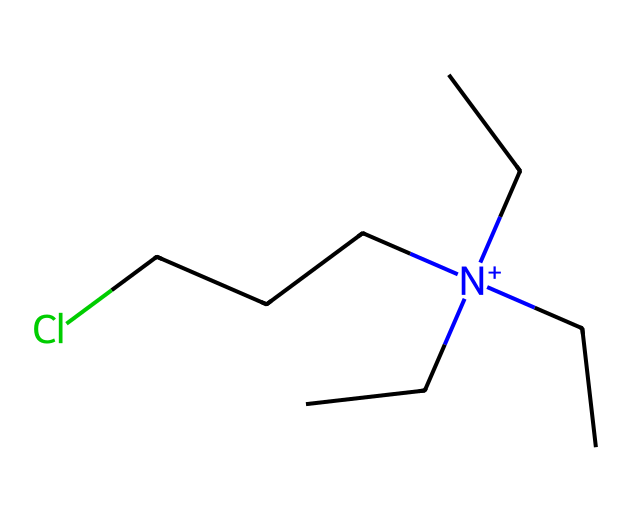What is the total number of carbon atoms in this compound? The SMILES representation shows multiple carbon atoms indicated by "C". Counting the number of "C" in the structure leads to a total of 7 carbon atoms.
Answer: 7 How many chlorine atoms are present in the chemical structure? The SMILES includes a "Cl" at the end, indicating one chlorine atom is bonded to the quaternary ammonium compound.
Answer: 1 What is the oxidation state of nitrogen in this compound? In quaternary ammonium compounds, the nitrogen usually has a +4 oxidation state due to the four alkyl groups attached and the positive charge displayed by "[N+]".
Answer: +4 What type of chemical is represented by this structure? The structure features a quaternary nitrogen atom and long carbon chains, characteristic of quaternary ammonium compounds, which are classified as disinfectants and biocides.
Answer: quaternary ammonium compound Describe the main functional group of this chemical. The main functional group is the quaternary ammonium ion, which is indicated by the nitrogen atom bonded to four hydrocarbons and carrying a positive charge.
Answer: quaternary ammonium ion How many hydrogen atoms are typically associated with this structure? Each carbon atom typically bonds with enough hydrogen atoms to satisfy carbon's tetravalency. With 7 carbons and assuming full saturation, this structure typically has around 15 hydrogen atoms, but actual counts might be fewer due to nitrogen and chlorine bonding.
Answer: 15 